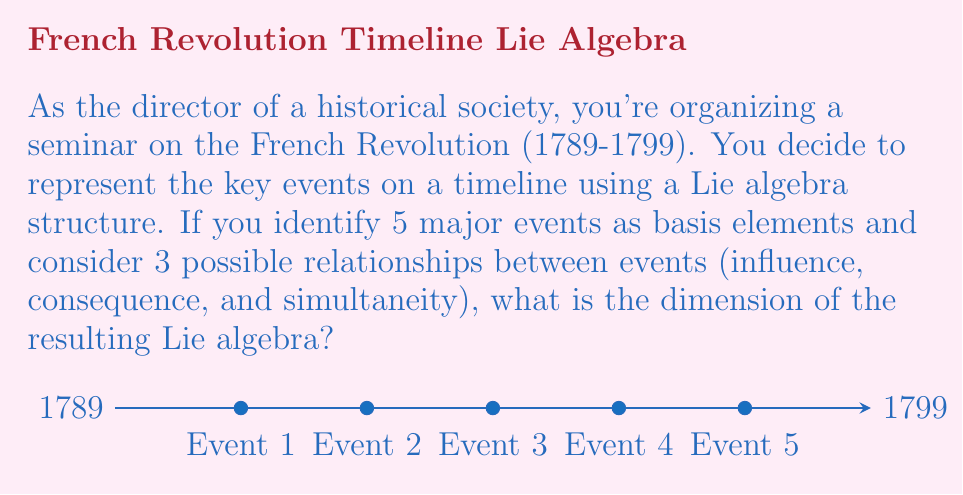Give your solution to this math problem. To determine the dimension of the Lie algebra, we need to follow these steps:

1) First, recall that the dimension of a Lie algebra is the sum of the dimension of its vector space and the number of possible Lie brackets.

2) The vector space dimension is given by the number of basis elements, which in this case is the number of major events: 5.

3) For the Lie brackets, we need to consider all possible pairs of events and the relationships between them. The number of possible pairs is given by the combination formula:

   $${n \choose 2} = \frac{n!}{2!(n-2)!}$$

   Where $n$ is the number of events (5 in this case).

4) Calculating:

   $$\frac{5!}{2!(5-2)!} = \frac{5 \cdot 4}{2} = 10$$

5) For each pair, we have 3 possible relationships (influence, consequence, and simultaneity). Therefore, the total number of possible Lie brackets is:

   $$10 \cdot 3 = 30$$

6) The dimension of the Lie algebra is the sum of the vector space dimension and the number of Lie brackets:

   $$5 + 30 = 35$$

Thus, the dimension of the Lie algebra associated with this historical timeline is 35.
Answer: 35 